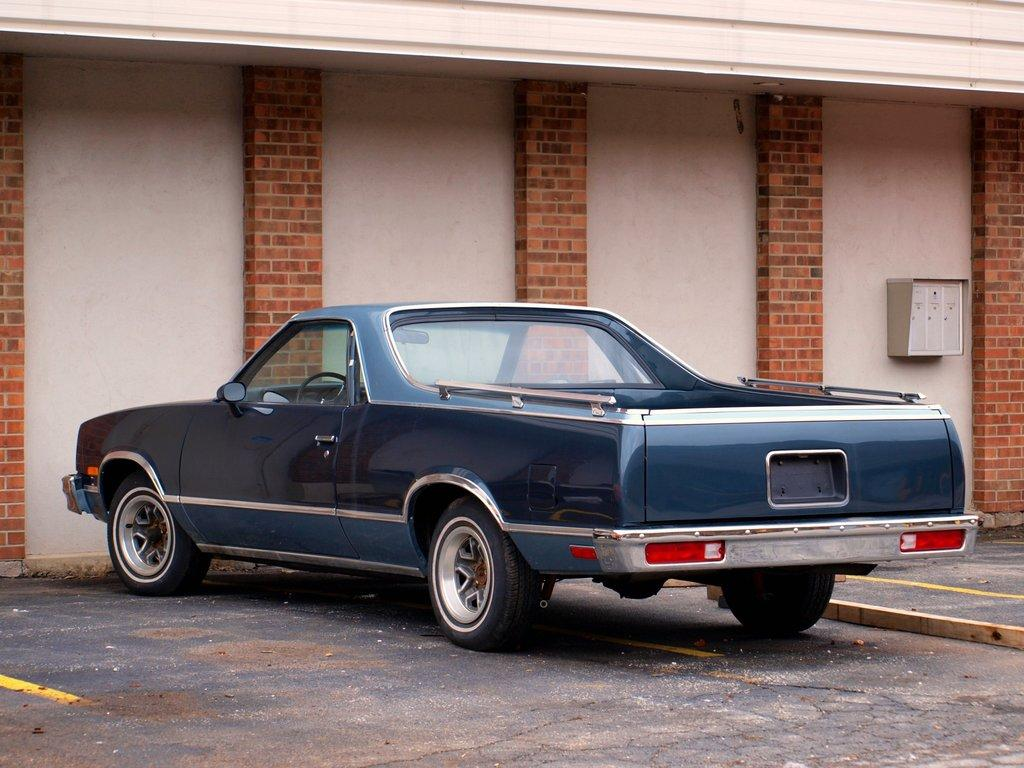What is the main subject in the image? There is a vehicle in the image. What can be seen beneath the vehicle? The ground is visible in the image. What is located near the vehicle? There is a wall in the image. Can you see a snake slithering on the ground in the image? There is no snake present in the image. What is the stomach of the vehicle in the image? The concept of a vehicle having a stomach is not applicable, as vehicles do not have stomachs. 